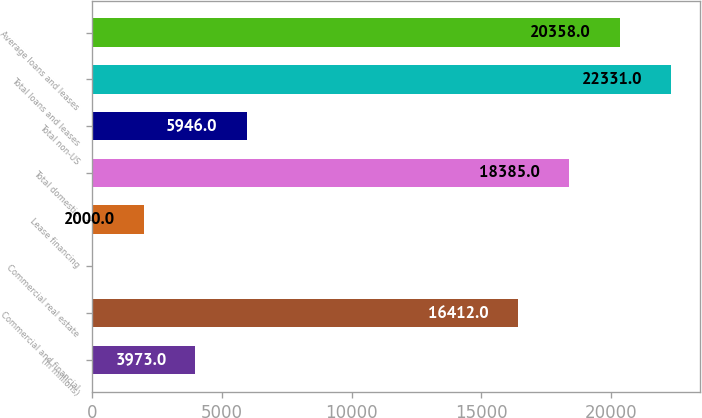<chart> <loc_0><loc_0><loc_500><loc_500><bar_chart><fcel>(In millions)<fcel>Commercial and financial<fcel>Commercial real estate<fcel>Lease financing<fcel>Total domestic<fcel>Total non-US<fcel>Total loans and leases<fcel>Average loans and leases<nl><fcel>3973<fcel>16412<fcel>27<fcel>2000<fcel>18385<fcel>5946<fcel>22331<fcel>20358<nl></chart> 